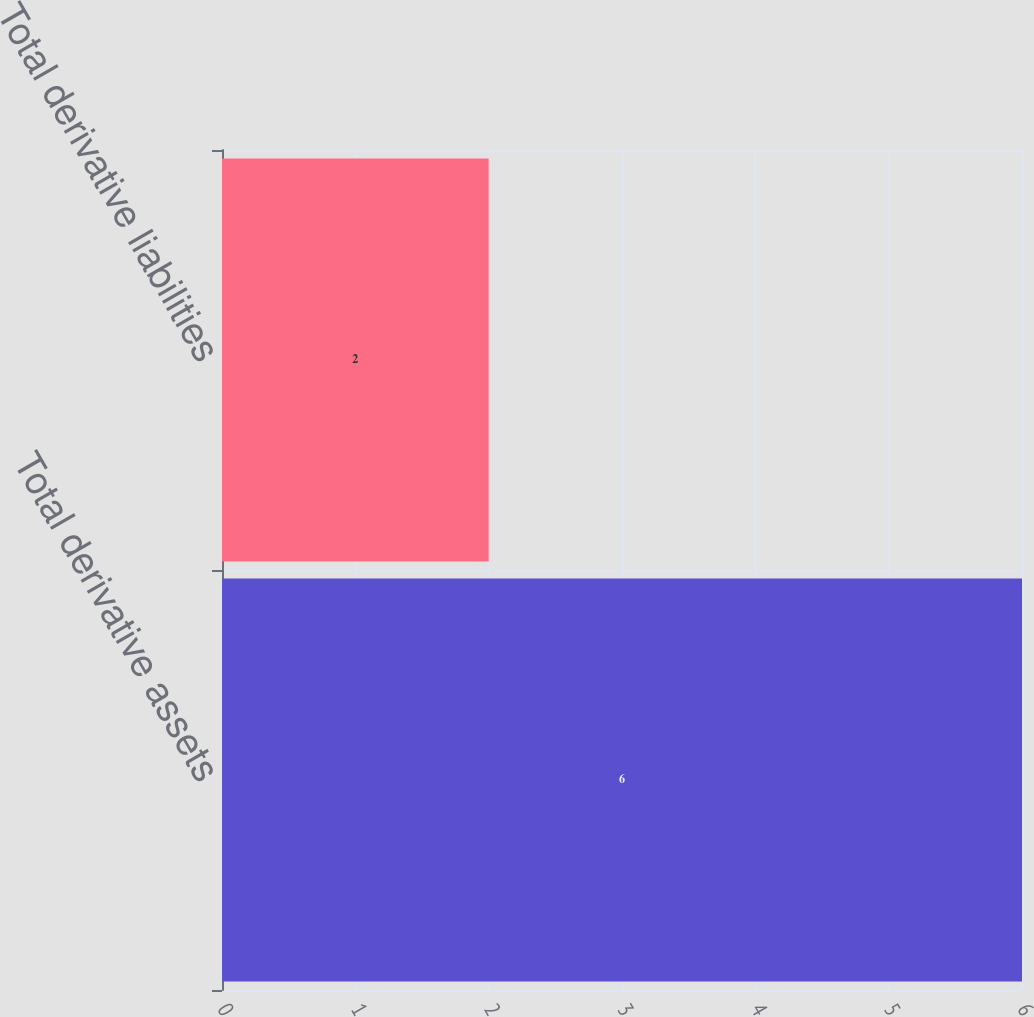Convert chart to OTSL. <chart><loc_0><loc_0><loc_500><loc_500><bar_chart><fcel>Total derivative assets<fcel>Total derivative liabilities<nl><fcel>6<fcel>2<nl></chart> 